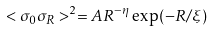<formula> <loc_0><loc_0><loc_500><loc_500>< \sigma _ { 0 } \sigma _ { R } > ^ { 2 } = A R ^ { - \eta } \exp ( - R / \xi )</formula> 